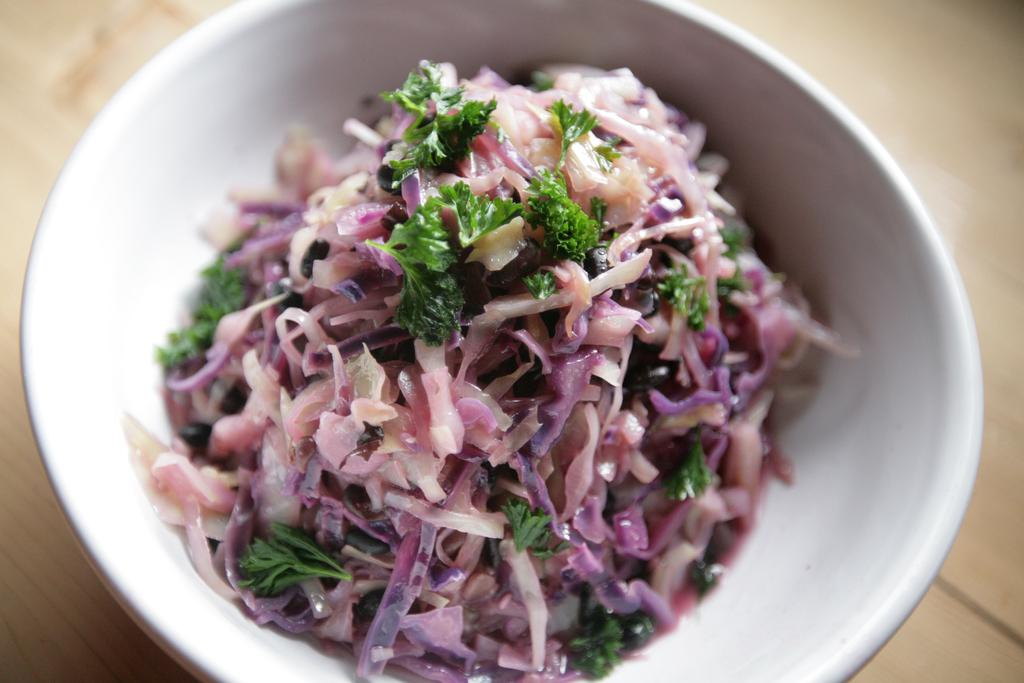What color is the bowl containing the food item in the image? The bowl is white. Where is the bowl located in the image? The bowl is in the middle of the image. What can be seen in the background of the image? There is a floor visible in the background of the image. Are there any cobwebs visible in the image? There is no mention of cobwebs in the provided facts, and therefore we cannot determine their presence in the image. 